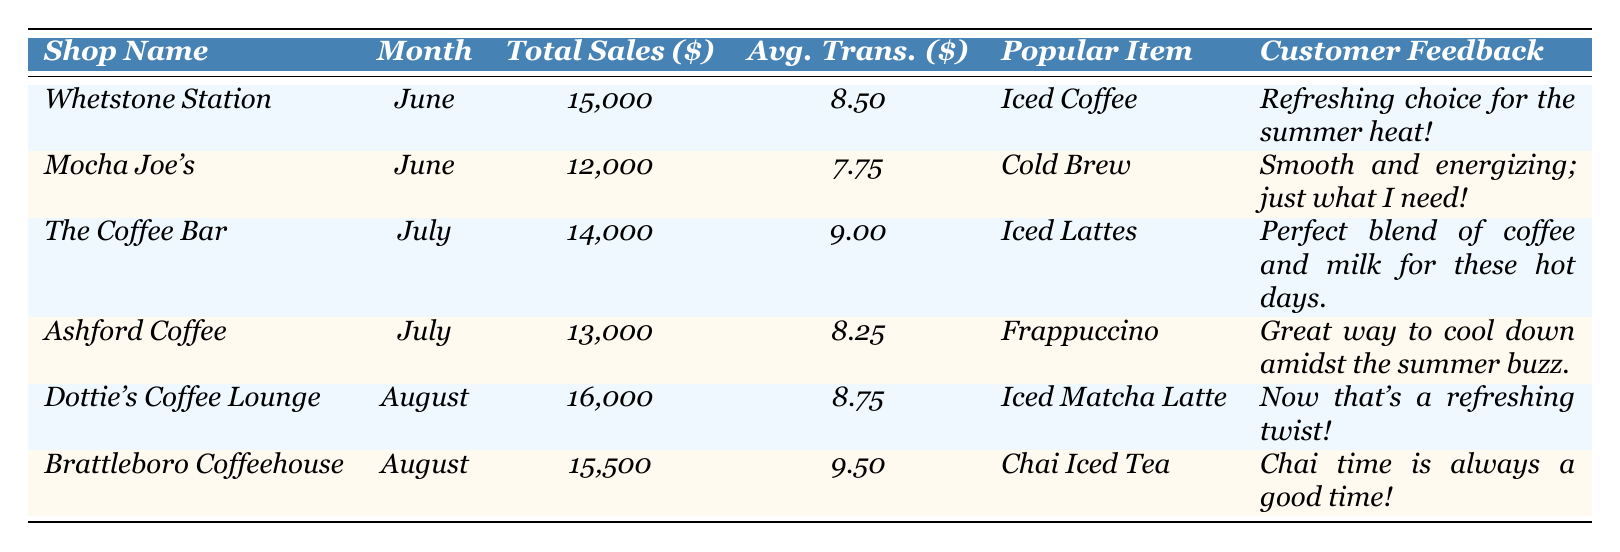What was the total sales for Dottie's Coffee Lounge in August? The table shows that Dottie's Coffee Lounge had total sales of $16,000 in August.
Answer: 16,000 Which shop had the highest average transaction value in July? The average transaction values for the shops in July are: The Coffee Bar - $9.00 and Ashford Coffee - $8.25. The Coffee Bar has the highest at $9.00.
Answer: $9.00 Did Mocha Joe's sell more than Whetstone Station in June? Mocha Joe's total sales were $12,000 and Whetstone Station's total sales were $15,000. Therefore, Mocha Joe's did not sell more.
Answer: No What is the average total sales of all the shops listed during the summer? Adding all the total sales: (15,000 + 12,000 + 14,000 + 13,000 + 16,000 + 15,500) = 85,500. There are 6 shops, so the average is 85,500/6 = 14,250.
Answer: 14,250 Which item received positive customer feedback at the highest sales shop in June? Whetstone Station had the highest total sales in June at $15,000 and the popular item was Iced Coffee, which received positive feedback.
Answer: Iced Coffee What was the total sales difference between Dottie's Coffee Lounge in August and Mocha Joe's in June? Dottie's total sales in August were $16,000 and Mocha Joe's in June were $12,000. The difference is $16,000 - $12,000 = $4,000.
Answer: $4,000 Which month had the most sales overall among all coffee shops? Total sales must be added by month: June = 27,000 (15,000 + 12,000), July = 27,000 (14,000 + 13,000), August = 31,500 (16,000 + 15,500). August has the highest sales at 31,500.
Answer: August How many of the coffee shops listed sold more than $14,000 in total sales? The shops with total sales above $14,000 are Dottie's Coffee Lounge (16,000), Brattleboro Coffeehouse (15,500), and Whetstone Station (15,000). This totals 3 shops.
Answer: 3 What was the most popular item sold at Ashford Coffee in July? The table shows that Ashford Coffee's most popular item was Frappuccino in July.
Answer: Frappuccino 